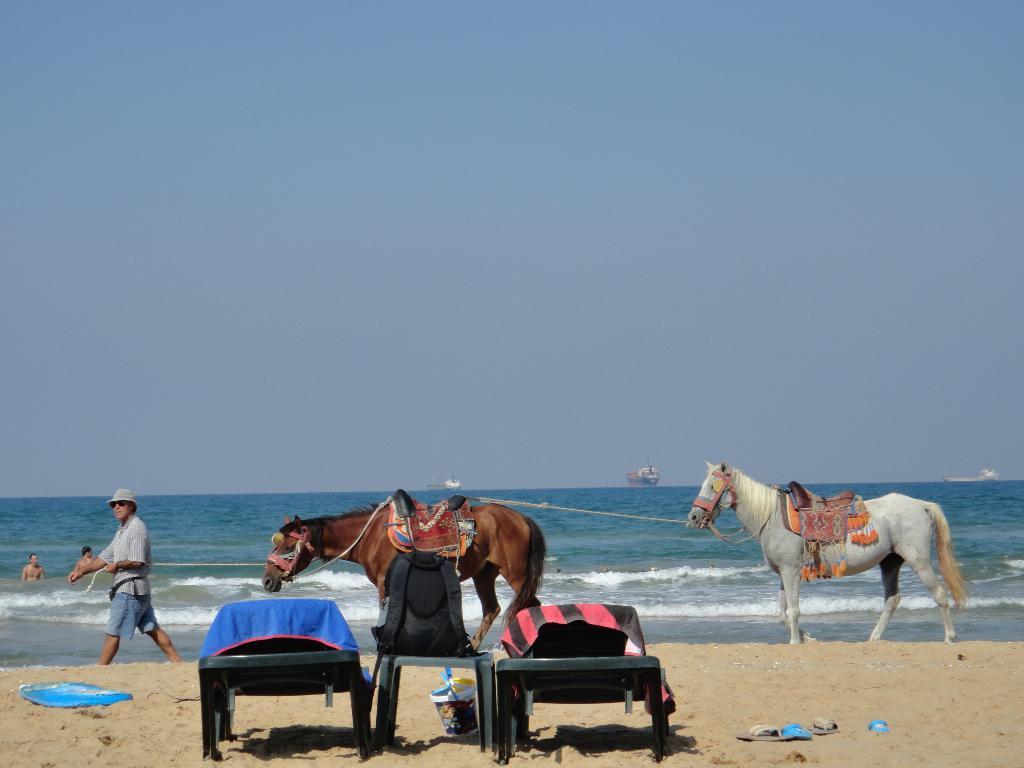Could you give a brief overview of what you see in this image? In this image two horses are on the land. They are tied with a rope. Left side a person is walking on the land. He is holding a rope. He is wearing a cap. Few people are in the water having tides. Few ships are sailing in water. There are chairs, table, bucket, footwear on the land. Left side there is a surfboard on the land. There is a bag on the table. Few clothes are on the chairs. Top of the image there is sky. 